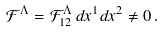Convert formula to latex. <formula><loc_0><loc_0><loc_500><loc_500>\mathcal { F } ^ { \Lambda } = \mathcal { F } _ { 1 2 } ^ { \Lambda } \, d x ^ { 1 } d x ^ { 2 } \neq 0 \, .</formula> 